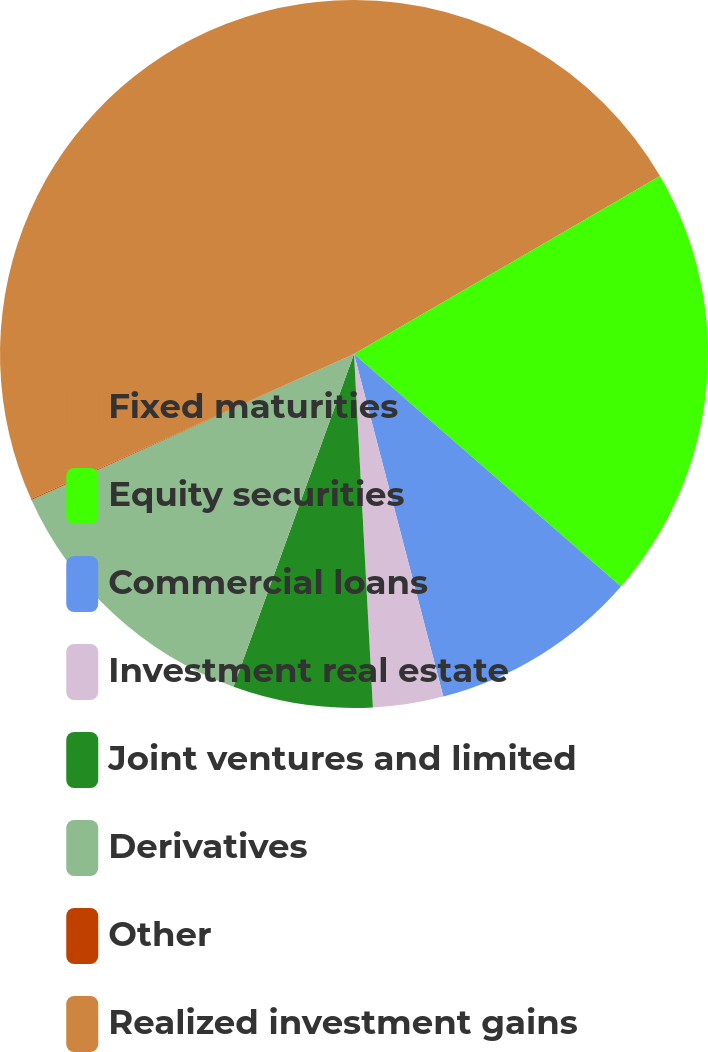Convert chart. <chart><loc_0><loc_0><loc_500><loc_500><pie_chart><fcel>Fixed maturities<fcel>Equity securities<fcel>Commercial loans<fcel>Investment real estate<fcel>Joint ventures and limited<fcel>Derivatives<fcel>Other<fcel>Realized investment gains<nl><fcel>16.62%<fcel>19.78%<fcel>9.54%<fcel>3.21%<fcel>6.38%<fcel>12.71%<fcel>0.04%<fcel>31.72%<nl></chart> 